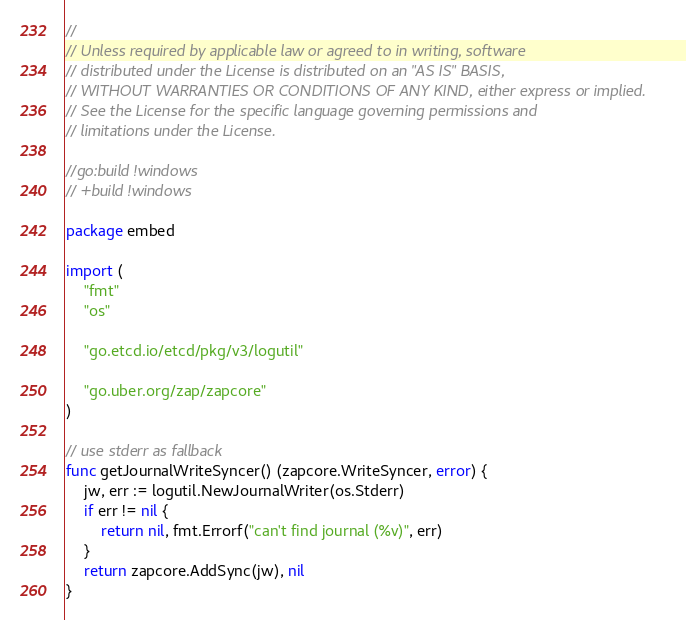<code> <loc_0><loc_0><loc_500><loc_500><_Go_>//
// Unless required by applicable law or agreed to in writing, software
// distributed under the License is distributed on an "AS IS" BASIS,
// WITHOUT WARRANTIES OR CONDITIONS OF ANY KIND, either express or implied.
// See the License for the specific language governing permissions and
// limitations under the License.

//go:build !windows
// +build !windows

package embed

import (
	"fmt"
	"os"

	"go.etcd.io/etcd/pkg/v3/logutil"

	"go.uber.org/zap/zapcore"
)

// use stderr as fallback
func getJournalWriteSyncer() (zapcore.WriteSyncer, error) {
	jw, err := logutil.NewJournalWriter(os.Stderr)
	if err != nil {
		return nil, fmt.Errorf("can't find journal (%v)", err)
	}
	return zapcore.AddSync(jw), nil
}
</code> 